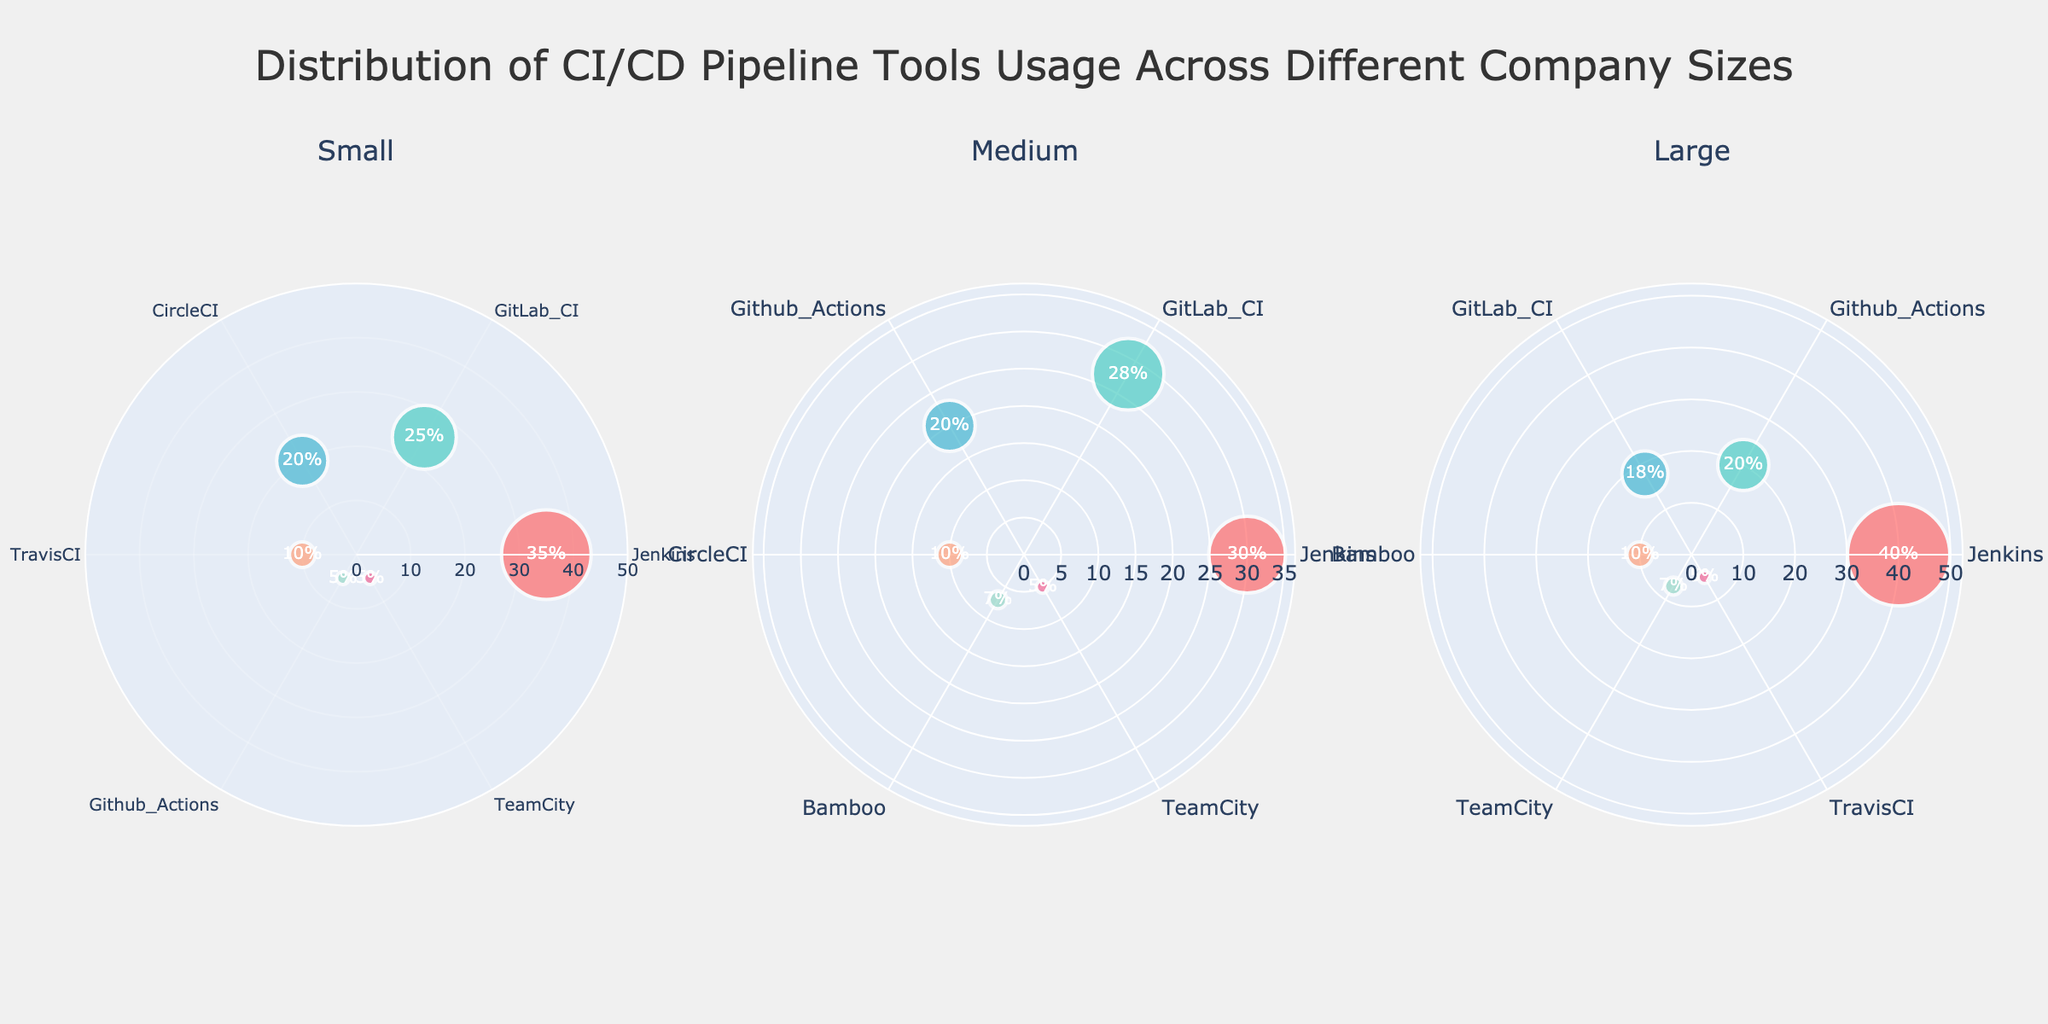What's the title of the figure? The title of the figure is typically located at the top of the chart and clearly describes the content. In this case, it reads "Distribution of CI/CD Pipeline Tools Usage Across Different Company Sizes."
Answer: Distribution of CI/CD Pipeline Tools Usage Across Different Company Sizes How many subplots are displayed in the figure? The figure features separate polar scatter plots for each company size. Each row has three subplots, one for small, one for medium, and one for large companies.
Answer: 3 Which tool has the highest usage percentage in large companies? To find the answer, examine the plot corresponding to large companies and identify the tool located farthest from the center, indicating the highest usage percentage. Jenkins has the highest usage at 40%.
Answer: Jenkins What is the combined usage percentage of TeamCity across all company sizes? First, identify the usage percentage of TeamCity in each subplot. For small companies, it is 5%. For medium companies, it is 5%. For large companies, it is 7%. Add these values together: 5% + 5% + 7% = 17%.
Answer: 17% Which tool is used equally by small and medium companies but not by large companies? Examine the radial distance in the polar plots for small and medium companies and find a tool with identical markers (5% for both demographics). TeamCity fits this criterion and is confirmed not to have the same value for large companies (7%).
Answer: TeamCity How does the usage of TravisCI compare between small and large companies? Look at the positions of TravisCI markers in the polar plots for both small and large companies. TravisCI has a usage percentage of 10% in small companies and 5% in large companies. Compare the two percentages: 10% vs. 5%.
Answer: Small companies: 10%, Large companies: 5% What is the mean percentage usage of GitLab CI across all company sizes? Identify the individual usage percentages for GitLab CI in each company size: Small (25%), Medium (28%), and Large (18%). Then, calculate the mean by summing these values and dividing by the number of data points: (25% + 28% + 18%) / 3 = 23.67%.
Answer: 23.67% What is the difference in usage percentage between the most used tool in medium companies and the least used tool in small companies? Identify the highest usage in medium companies (Jenkins at 30%) and the lowest in small companies (GitHub Actions and TeamCity at 5%). Subtract the lowest from the highest: 30% - 5% = 25%.
Answer: 25% Which company size shows the most diversified usage of tools, as indicated by variation in marker positions? Diversification can be determined by observing the spread of marker positions across the angular axis in each subplot. Medium companies show a wider spread of usage percentages across more tools (highest marker variety).
Answer: Medium What is the median usage percentage of CI/CD tools in small companies? List all usage percentages for small companies: 35%, 25%, 20%, 10%, 5%, and 5%. Arrange them in ascending order: 5%, 5%, 10%, 20%, 25%, 35%. The median is the middle value or average of the middle two values (in case of an even number of data points): (10% + 20%) / 2 = 15%.
Answer: 15% 